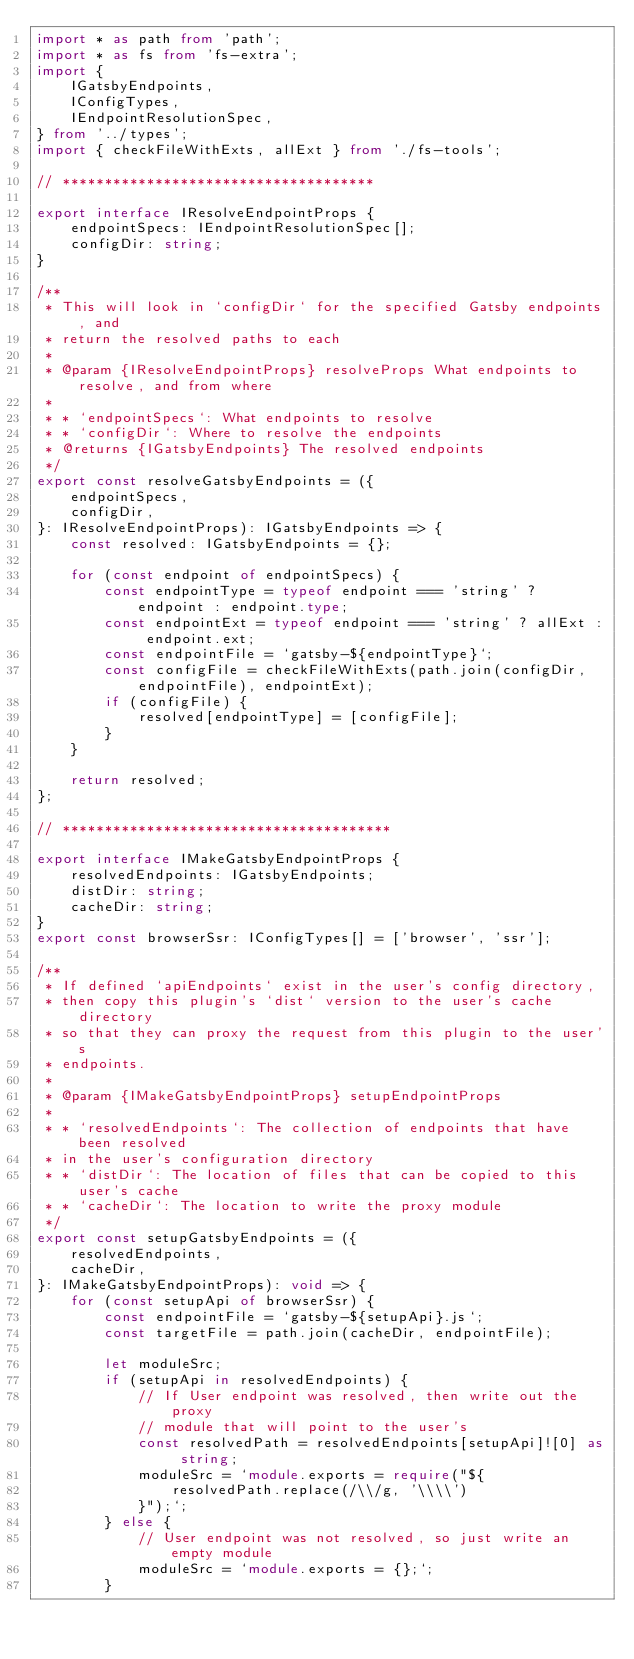Convert code to text. <code><loc_0><loc_0><loc_500><loc_500><_TypeScript_>import * as path from 'path';
import * as fs from 'fs-extra';
import {
    IGatsbyEndpoints,
    IConfigTypes,
    IEndpointResolutionSpec,
} from '../types';
import { checkFileWithExts, allExt } from './fs-tools';

// *************************************

export interface IResolveEndpointProps {
    endpointSpecs: IEndpointResolutionSpec[];
    configDir: string;
}

/**
 * This will look in `configDir` for the specified Gatsby endpoints, and
 * return the resolved paths to each
 *
 * @param {IResolveEndpointProps} resolveProps What endpoints to resolve, and from where
 *
 * * `endpointSpecs`: What endpoints to resolve
 * * `configDir`: Where to resolve the endpoints
 * @returns {IGatsbyEndpoints} The resolved endpoints
 */
export const resolveGatsbyEndpoints = ({
    endpointSpecs,
    configDir,
}: IResolveEndpointProps): IGatsbyEndpoints => {
    const resolved: IGatsbyEndpoints = {};

    for (const endpoint of endpointSpecs) {
        const endpointType = typeof endpoint === 'string' ? endpoint : endpoint.type;
        const endpointExt = typeof endpoint === 'string' ? allExt : endpoint.ext;
        const endpointFile = `gatsby-${endpointType}`;
        const configFile = checkFileWithExts(path.join(configDir, endpointFile), endpointExt);
        if (configFile) {
            resolved[endpointType] = [configFile];
        }
    }

    return resolved;
};

// ***************************************

export interface IMakeGatsbyEndpointProps {
    resolvedEndpoints: IGatsbyEndpoints;
    distDir: string;
    cacheDir: string;
}
export const browserSsr: IConfigTypes[] = ['browser', 'ssr'];

/**
 * If defined `apiEndpoints` exist in the user's config directory,
 * then copy this plugin's `dist` version to the user's cache directory
 * so that they can proxy the request from this plugin to the user's
 * endpoints.
 *
 * @param {IMakeGatsbyEndpointProps} setupEndpointProps
 *
 * * `resolvedEndpoints`: The collection of endpoints that have been resolved
 * in the user's configuration directory
 * * `distDir`: The location of files that can be copied to this user's cache
 * * `cacheDir`: The location to write the proxy module
 */
export const setupGatsbyEndpoints = ({
    resolvedEndpoints,
    cacheDir,
}: IMakeGatsbyEndpointProps): void => {
    for (const setupApi of browserSsr) {
        const endpointFile = `gatsby-${setupApi}.js`;
        const targetFile = path.join(cacheDir, endpointFile);

        let moduleSrc;
        if (setupApi in resolvedEndpoints) {
            // If User endpoint was resolved, then write out the proxy
            // module that will point to the user's
            const resolvedPath = resolvedEndpoints[setupApi]![0] as string;
            moduleSrc = `module.exports = require("${
                resolvedPath.replace(/\\/g, '\\\\')
            }");`;
        } else {
            // User endpoint was not resolved, so just write an empty module
            moduleSrc = `module.exports = {};`;
        }</code> 